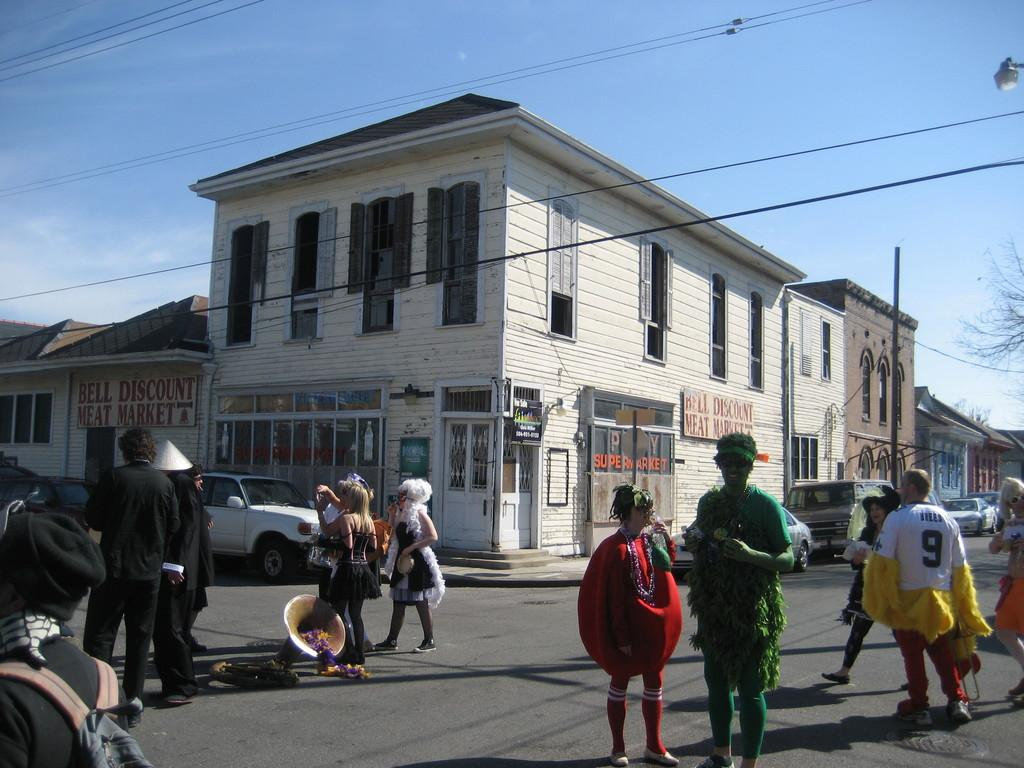What type of structure is the main subject in the image? There is a shop building in the image. How many buildings are located near the shop building? There are three buildings beside the shop building. What can be seen in front of the buildings? There are cars in front of the buildings. What is notable about the people on the road? There are people with different costumes on the road. What book is the person holding while walking on the road? There is no person holding a book in the image; the people on the road are wearing different costumes. 